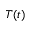Convert formula to latex. <formula><loc_0><loc_0><loc_500><loc_500>T ( t )</formula> 